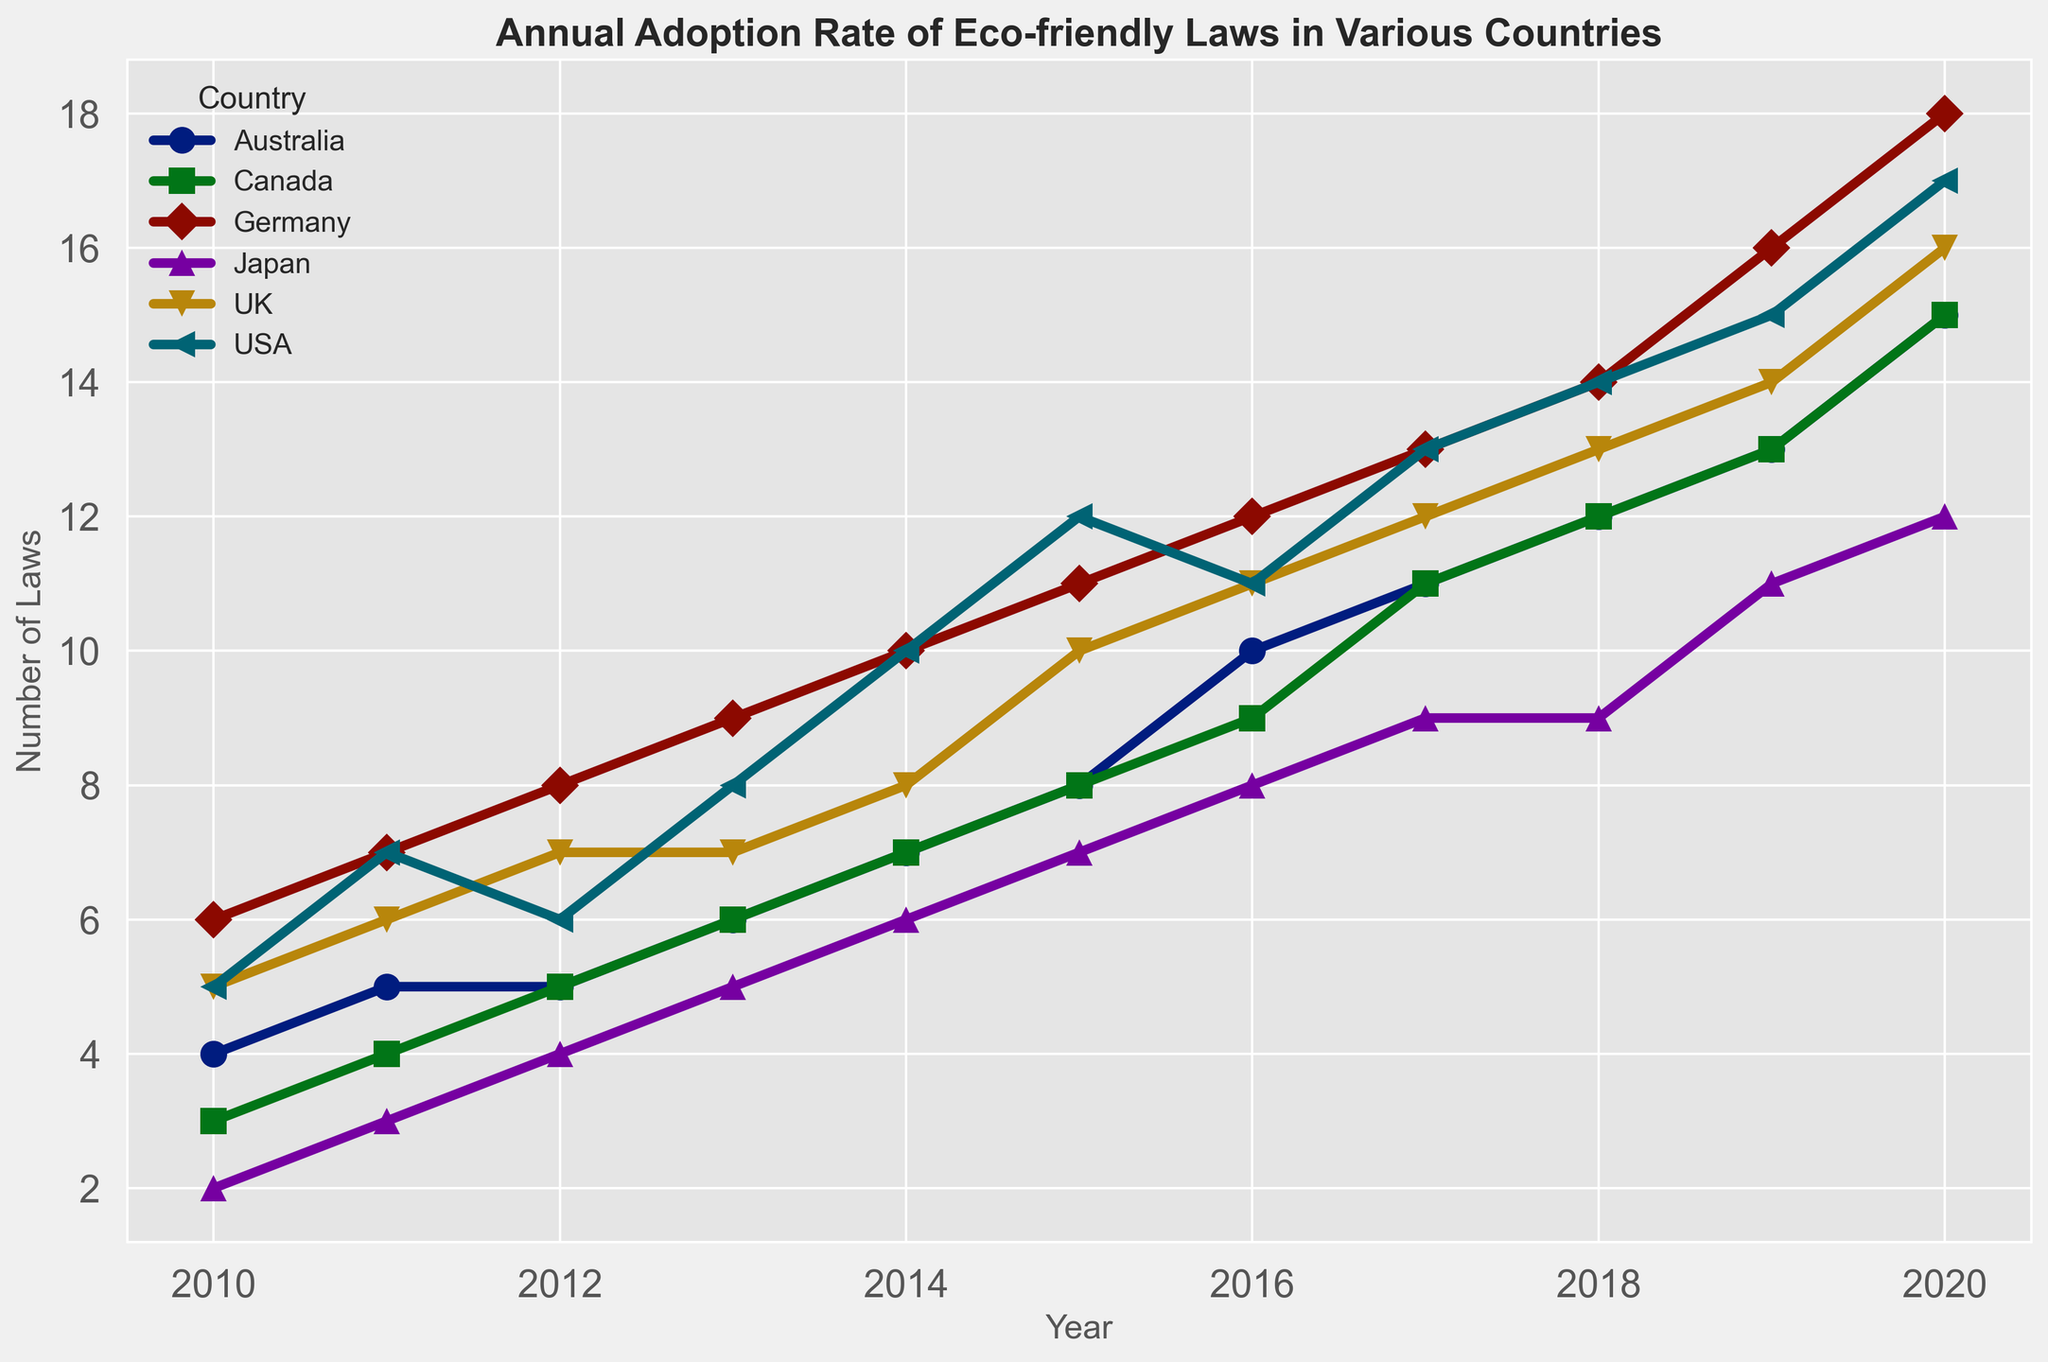Which country first reached 10 eco-friendly laws? Look at the plot and find the earliest year where the number of laws reached 10 for each country. The USA first reached 10 laws in 2014.
Answer: USA Which country showed the steepest increase in the number of laws from 2019 to 2020? Check the lines from 2019 to 2020 for each country and see which one has the steepest upward slope. Germany increased from 16 to 18 laws, which is 2 laws. USA increased from 15 to 17, also 2. Canada increased from 13 to 15, 2 again. The largest increase is 3 laws for the UK from 14 to 16 and for Australia from 13 to 15, tied.
Answer: UK and Australia Which country had the most consistent increase in eco-friendly laws from 2010 to 2020? Look for a line with the least fluctuation and the most steady increase. Canada's line shows a consistent steady increase every year.
Answer: Canada By how much did Japan's number of eco-friendly laws increase from 2010 to 2020? Japan had 2 laws in 2010 and 12 laws in 2020. Subtract 2 from 12 to find the increase. 12 - 2 = 10.
Answer: 10 Which country had the highest total number of eco-friendly laws in 2020? Look at the end values of each line in the plot for the year 2020. Germany has 18 laws which is the highest among all the countries listed.
Answer: Germany Compare the growth rate of eco-friendly laws in the USA and UK from 2015 to 2020. Which one grew faster? Calculate the difference in the number of laws for each country between 2015 and 2020. The USA had 12 laws in 2015 and 17 in 2020; the increase is 5 laws. The UK had 10 laws in 2015 and 16 in 2020, the increase is 6 laws. The UK grew faster.
Answer: UK Which country had the sharpest decline in any year from 2010 to 2020? Look for any downwards slopes in the lines for each country. The USA had a decline from 2015 to 2016, where it went from 12 laws to 11 laws, showing the sharpest decline on the plot as other countries did not show a decline.
Answer: USA What is the average number of eco-friendly laws adopted in Canada from 2010 to 2020? Sum all the values for Canada and divide by the number of years (11). The values are 3+4+5+6+7+8+9+11+12+13+15 = 93. 93 / 11 = 8.45.
Answer: 8.45 